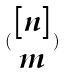<formula> <loc_0><loc_0><loc_500><loc_500>( \begin{matrix} [ n ] \\ m \end{matrix} )</formula> 